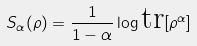<formula> <loc_0><loc_0><loc_500><loc_500>S _ { \alpha } ( \rho ) = \frac { 1 } { 1 - \alpha } \log \text {tr} [ \rho ^ { \alpha } ]</formula> 